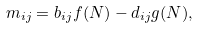Convert formula to latex. <formula><loc_0><loc_0><loc_500><loc_500>m _ { i j } = b _ { i j } f ( N ) - d _ { i j } g ( N ) ,</formula> 